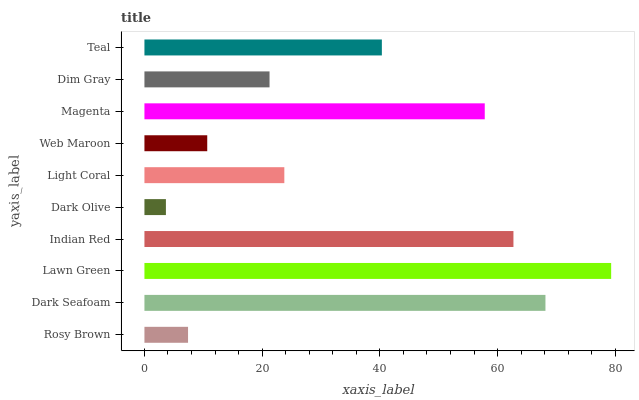Is Dark Olive the minimum?
Answer yes or no. Yes. Is Lawn Green the maximum?
Answer yes or no. Yes. Is Dark Seafoam the minimum?
Answer yes or no. No. Is Dark Seafoam the maximum?
Answer yes or no. No. Is Dark Seafoam greater than Rosy Brown?
Answer yes or no. Yes. Is Rosy Brown less than Dark Seafoam?
Answer yes or no. Yes. Is Rosy Brown greater than Dark Seafoam?
Answer yes or no. No. Is Dark Seafoam less than Rosy Brown?
Answer yes or no. No. Is Teal the high median?
Answer yes or no. Yes. Is Light Coral the low median?
Answer yes or no. Yes. Is Web Maroon the high median?
Answer yes or no. No. Is Teal the low median?
Answer yes or no. No. 